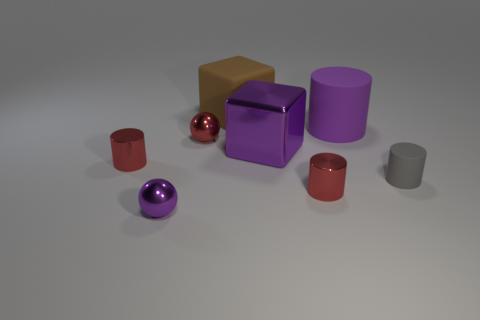Subtract all tiny gray rubber cylinders. How many cylinders are left? 3 Subtract 4 cylinders. How many cylinders are left? 0 Add 2 big yellow things. How many objects exist? 10 Subtract all purple cubes. How many cubes are left? 1 Subtract 1 purple spheres. How many objects are left? 7 Subtract all blocks. How many objects are left? 6 Subtract all yellow spheres. Subtract all green cylinders. How many spheres are left? 2 Subtract all yellow spheres. How many yellow cubes are left? 0 Subtract all large purple cubes. Subtract all small purple spheres. How many objects are left? 6 Add 3 tiny red shiny balls. How many tiny red shiny balls are left? 4 